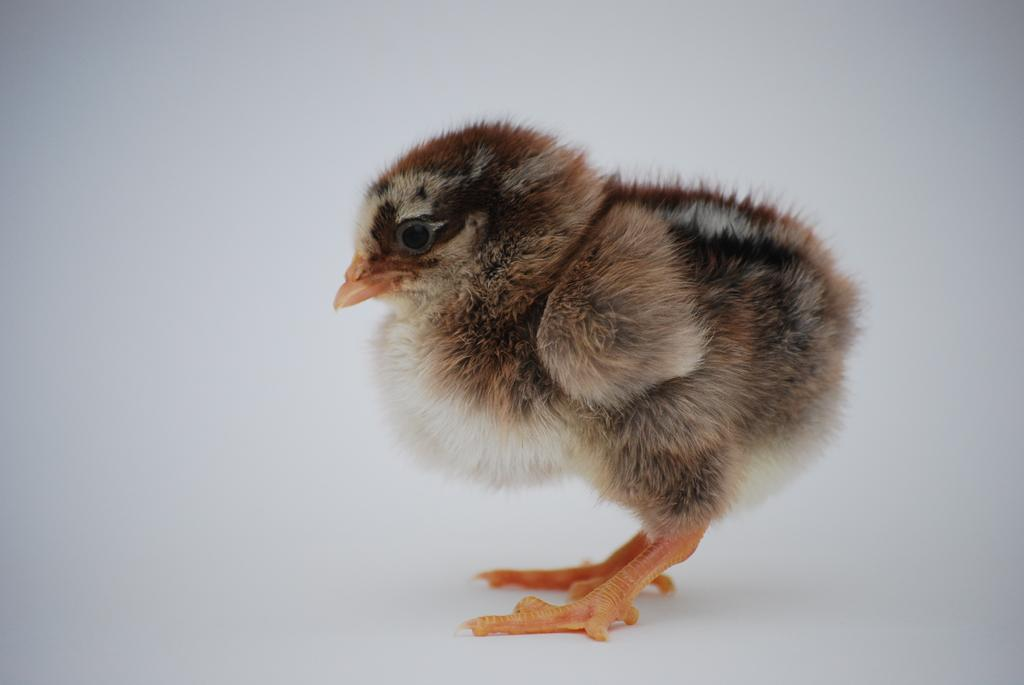What type of animal is in the image? There is a bird in the image. Can you describe the bird's colors? The bird has brown, white, and black colors. What is the color of the background in the image? The background of the image is white. What type of laborer is working in the image? There is no laborer present in the image; it features a bird with brown, white, and black colors against a white background. Can you see any bubbles in the image? There are no bubbles present in the image. 